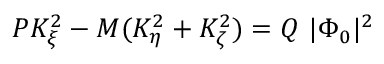Convert formula to latex. <formula><loc_0><loc_0><loc_500><loc_500>P K _ { \xi } ^ { 2 } - M ( K _ { \eta } ^ { 2 } + K _ { \zeta } ^ { 2 } ) = Q | \Phi _ { 0 } | ^ { 2 }</formula> 